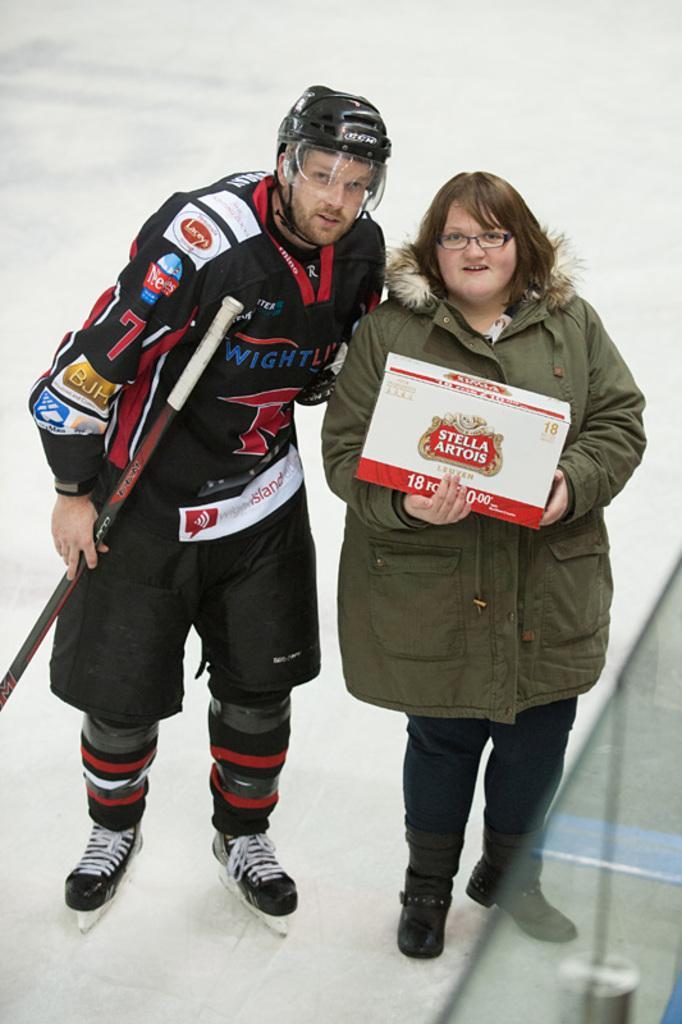In one or two sentences, can you explain what this image depicts? In the image we can see a man and a woman standing and wearing clothes. The man is wearing a helmet, snow skiing shoes and holding a stick in hand. The woman is holding box is her hand and she is wearing spectacles. Here we can see the snow.. 